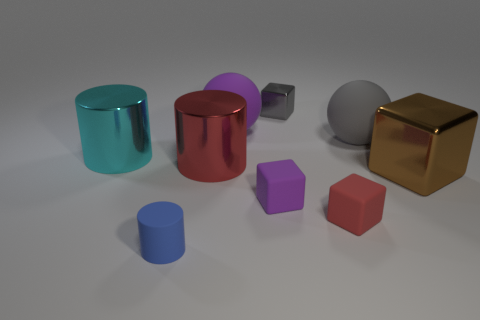Add 1 purple rubber things. How many objects exist? 10 Subtract all cylinders. How many objects are left? 6 Subtract all small gray blocks. Subtract all small purple rubber objects. How many objects are left? 7 Add 5 brown cubes. How many brown cubes are left? 6 Add 4 small purple matte blocks. How many small purple matte blocks exist? 5 Subtract 0 blue blocks. How many objects are left? 9 